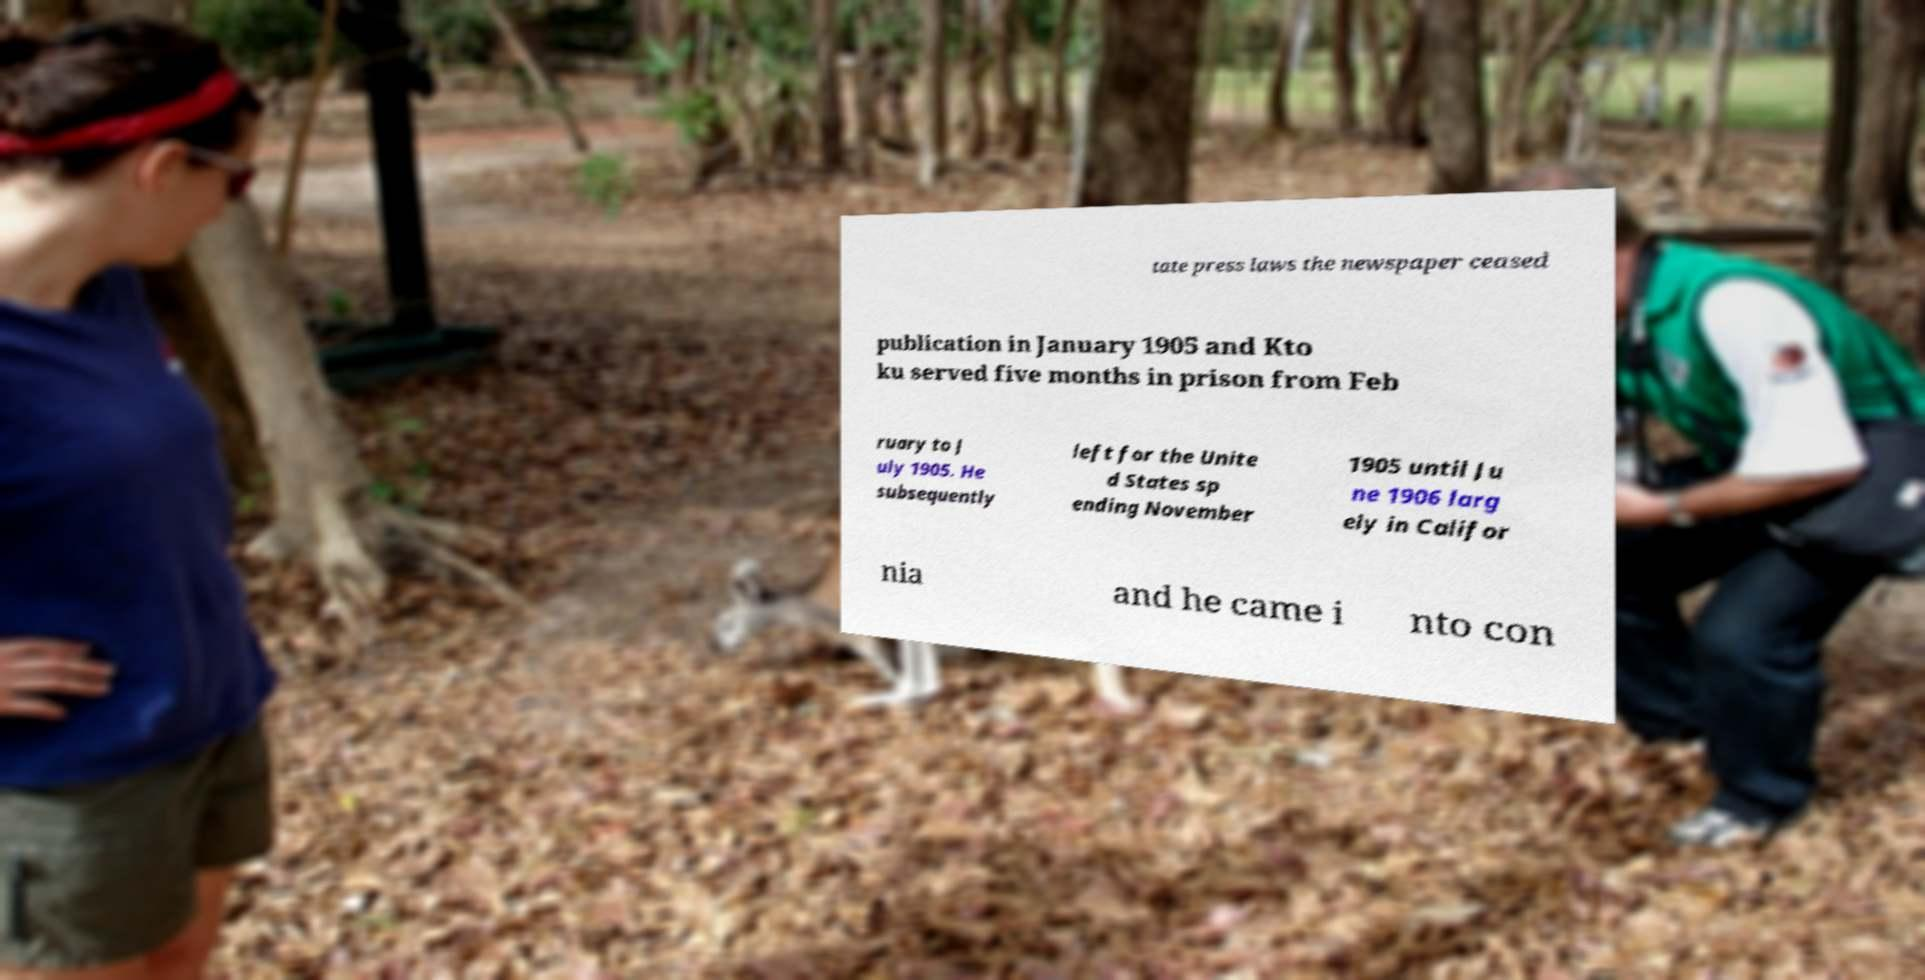I need the written content from this picture converted into text. Can you do that? tate press laws the newspaper ceased publication in January 1905 and Kto ku served five months in prison from Feb ruary to J uly 1905. He subsequently left for the Unite d States sp ending November 1905 until Ju ne 1906 larg ely in Califor nia and he came i nto con 